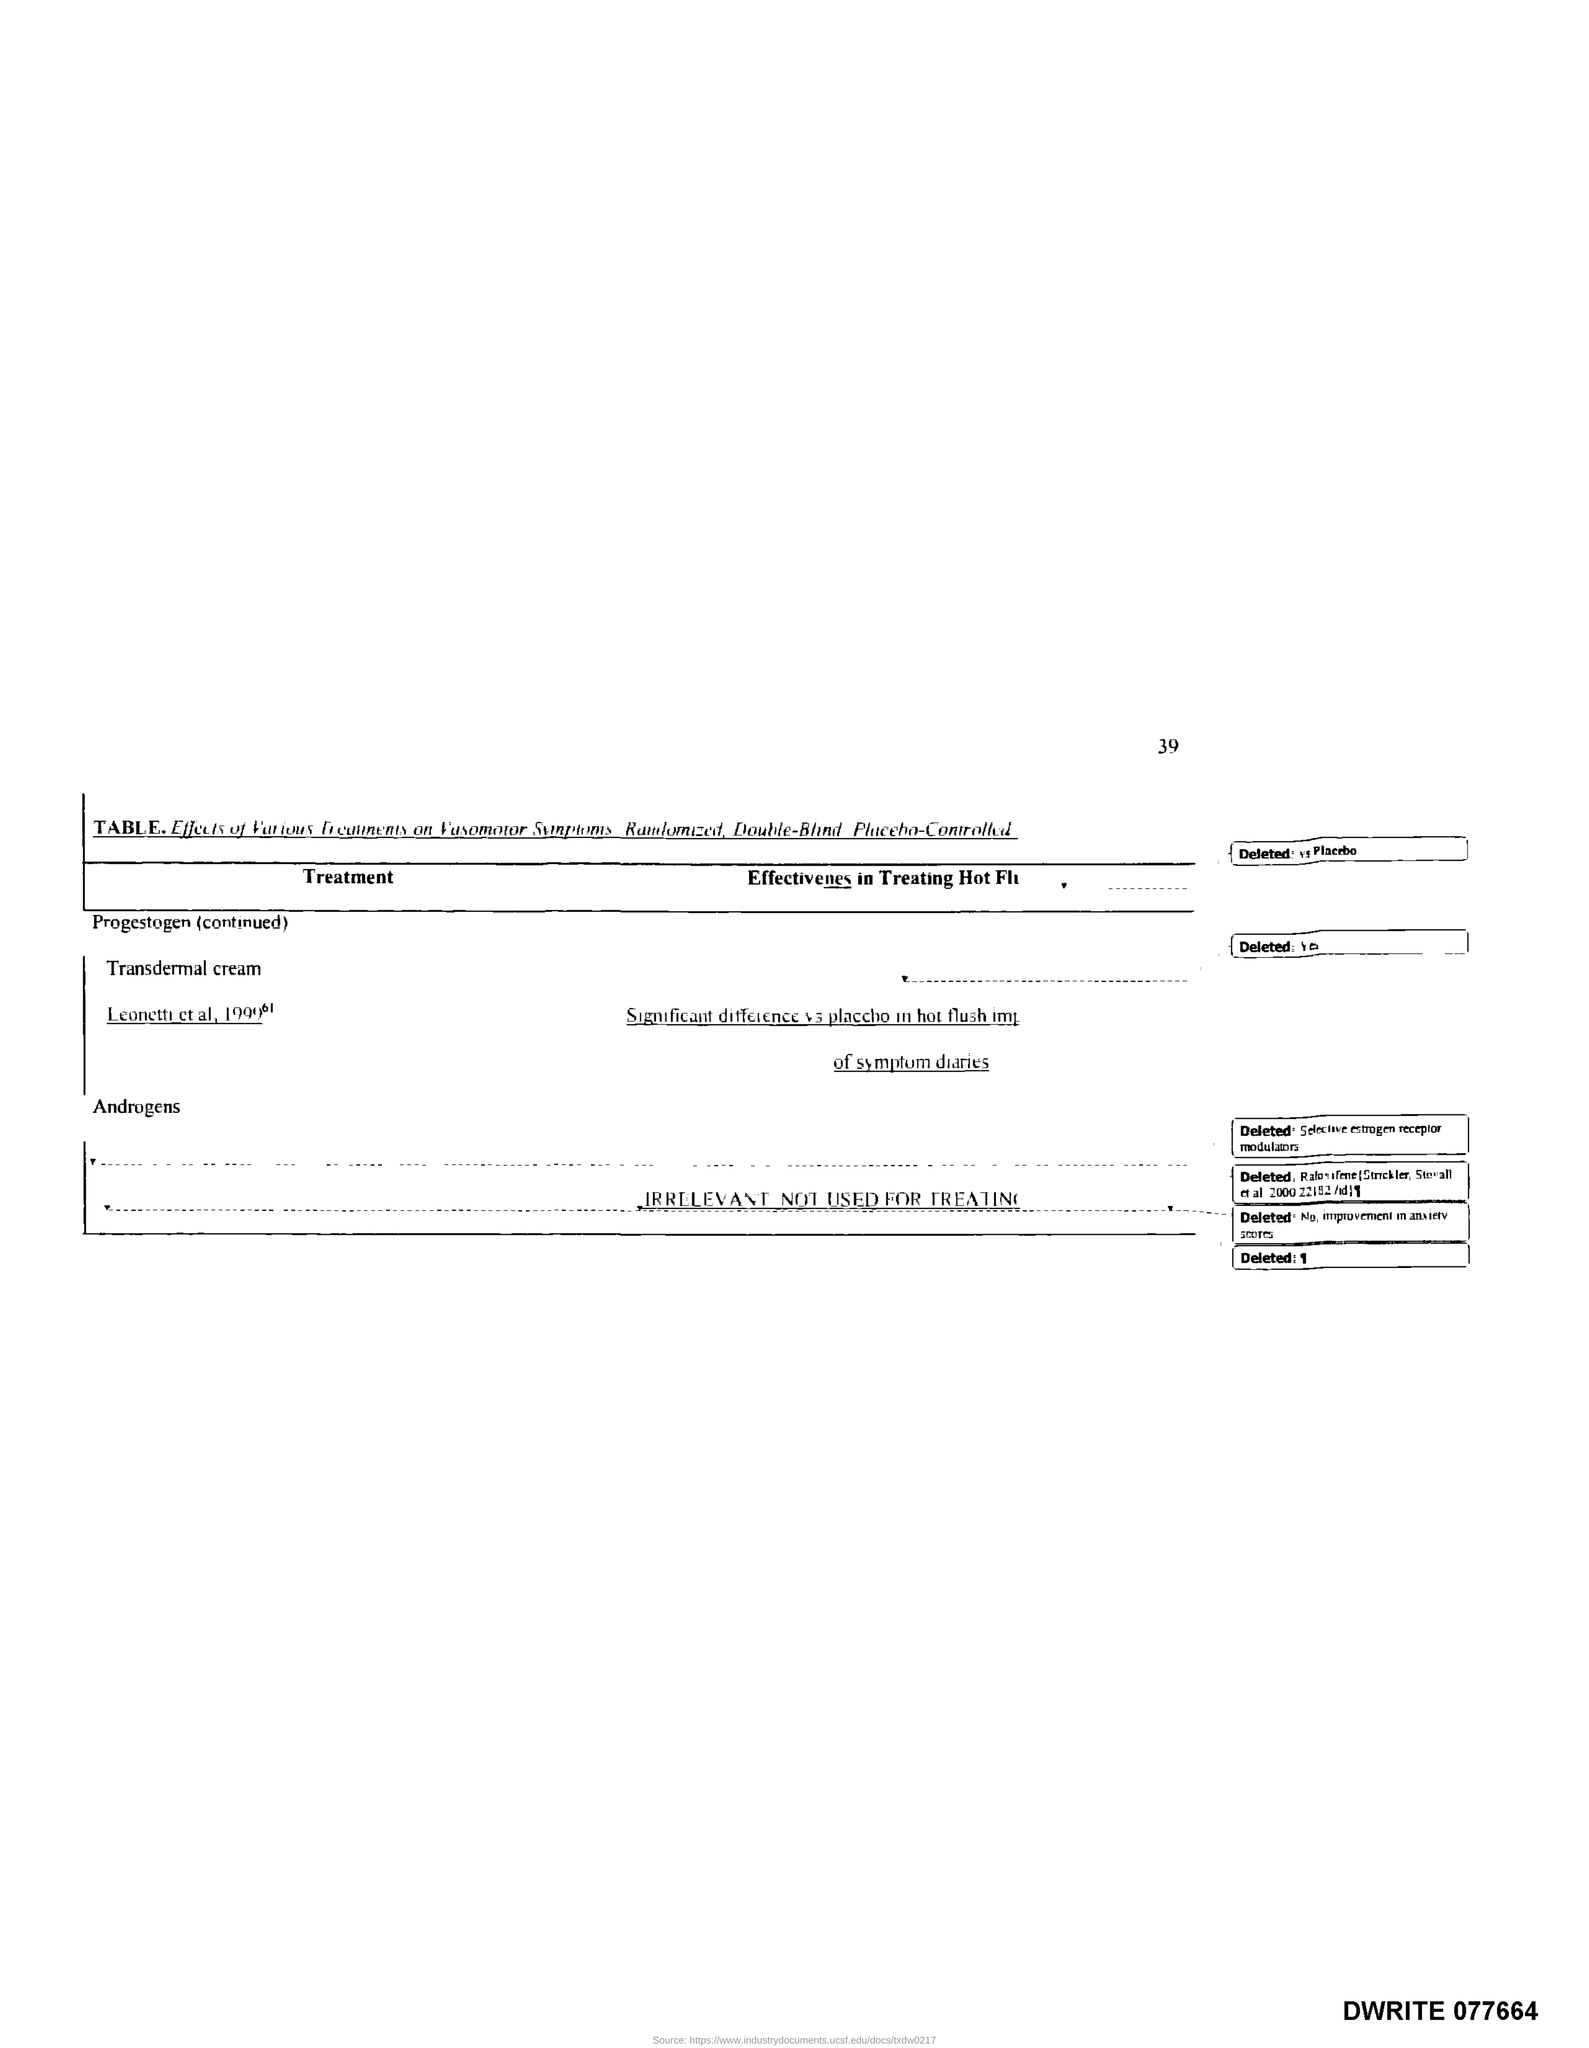What is the page number?
Offer a terse response. 39. What is the title of the first column of the table?
Make the answer very short. Treatment. 